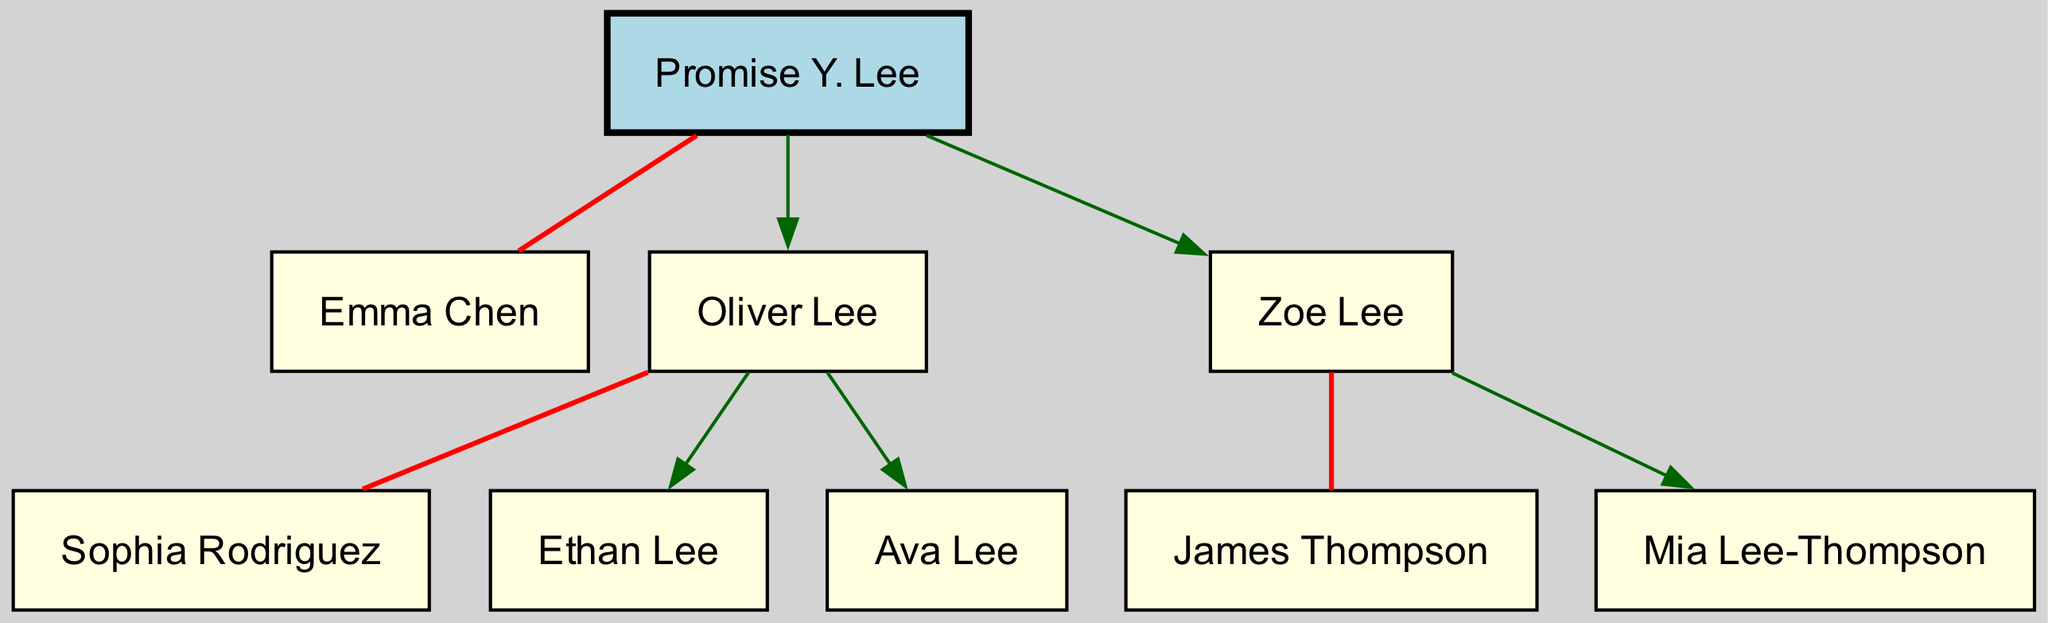What is the name of Promise Y. Lee's spouse? The diagram indicates that Promise Y. Lee is married to Emma Chen, as shown directly connected to her in the family tree.
Answer: Emma Chen How many children does Promise Y. Lee have? According to the diagram, Promise Y. Lee has two children: Oliver Lee and Zoe Lee. This count is derived from the listed children under Promise Y. Lee’s node.
Answer: 2 Who is the spouse of Oliver Lee? The diagram shows that Oliver Lee is married to Sophia Rodriguez, which can be seen under the Oliver Lee node connected by a marriage line.
Answer: Sophia Rodriguez List the names of Promise Y. Lee's grandchildren. The diagram illustrates that Promise Y. Lee has three grandchildren: Ethan Lee, Ava Lee, and Mia Lee-Thompson. The names can be found directly connected to their respective parents in the tree structure.
Answer: Ethan Lee, Ava Lee, Mia Lee-Thompson Which of Promise Y. Lee's children has a spouse named James Thompson? The diagram specifies that Zoe Lee is the child married to James Thompson, as indicated by the direct connection shown in the family tree.
Answer: Zoe Lee How many grandchildren does Oliver Lee have? Based on the diagram, Oliver Lee has two children: Ethan Lee and Ava Lee. Therefore, Oliver Lee has two grandchildren. This is determined by counting the listed children under Oliver Lee's node.
Answer: 2 Is there a direct connection between Ethan Lee and Emma Chen? The diagram does not show a direct connection between Ethan Lee and Emma Chen. Ethan Lee is a grandchild of Promise Y. Lee and does not connect directly to Emma Chen in the tree structure.
Answer: No What color is the node representing Promise Y. Lee? The diagram indicates that Promise Y. Lee's node is colored light blue, as specified in the design attributes set for the root person in the graph.
Answer: Light blue 